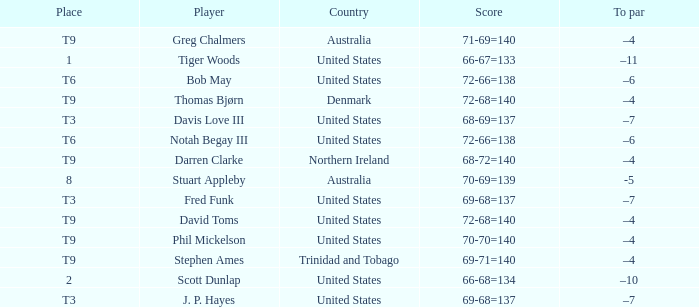What country is Stephen Ames from with a place value of t9? Trinidad and Tobago. 